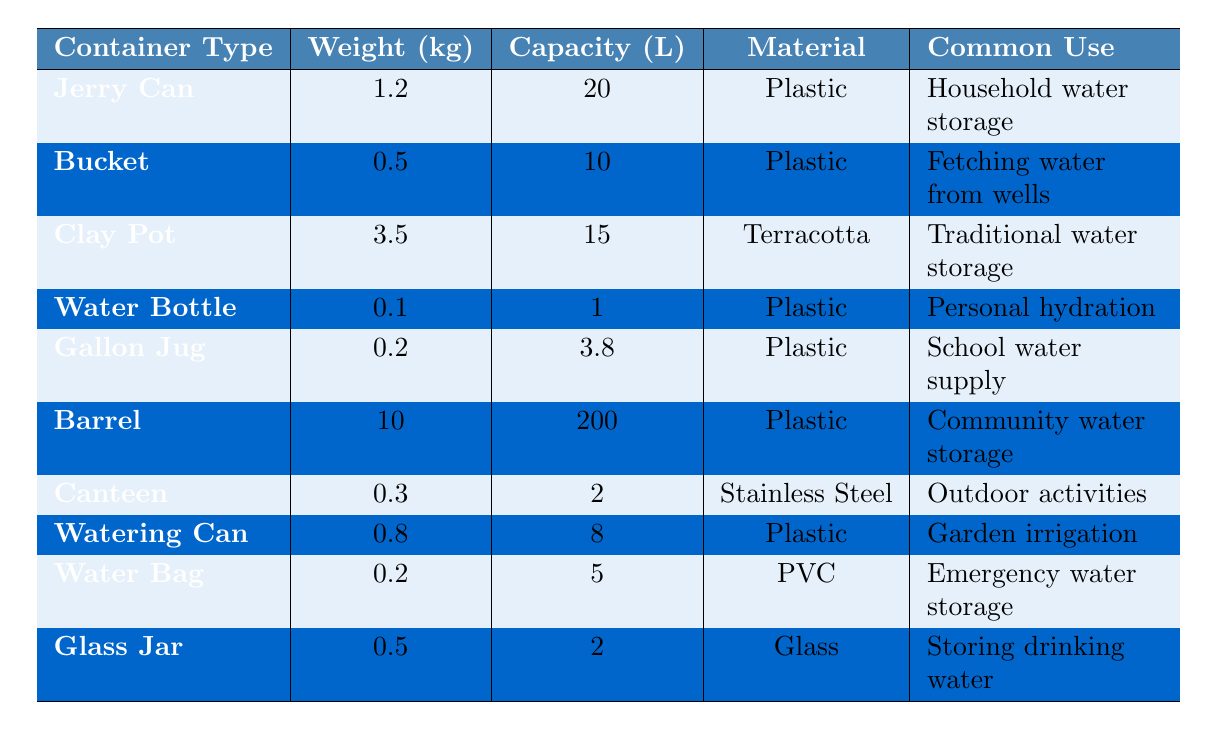What's the weight of a jerry can? The table lists the weight of a jerry can as 1.2 kg.
Answer: 1.2 kg Which container has the largest capacity? The barrel has the largest capacity of 200 liters, as seen in the table.
Answer: 200 liters How much does a clay pot weigh compared to a water bag? A clay pot weighs 3.5 kg, while a water bag weighs 0.2 kg. The difference is 3.5 - 0.2 = 3.3 kg, meaning the clay pot is heavier by this amount.
Answer: 3.3 kg Is the water bottle heavier than the gallon jug? The weight of the water bottle is 0.1 kg, while the gallon jug weighs 0.2 kg; thus, the water bottle is lighter.
Answer: No What is the average capacity of the containers listed? To find the average capacity, sum the capacities: 20 + 10 + 15 + 1 + 3.8 + 200 + 2 + 8 + 5 + 2 = 272. Then divide by the number of containers (10): 272 / 10 = 27.2 liters.
Answer: 27.2 liters Which materials are used for the containers? The materials used are plastic, terracotta, stainless steel, and glass. This can be identified by looking at the "Material" column in the table.
Answer: Plastic, terracotta, stainless steel, glass How many containers are made of plastic? The table shows that there are 6 containers made of plastic: Jerry Can, Bucket, Gallon Jug, Barrel, Watering Can, and Water Bag.
Answer: 6 What is the total weight of all the containers combined? To find the total weight, convert the weights to numbers and sum them up: 1.2 + 0.5 + 3.5 + 0.1 + 0.2 + 10 + 0.3 + 0.8 + 0.2 + 0.5 = 17.8 kg.
Answer: 17.8 kg Which container is commonly used for emergency water storage? The water bag is commonly used for emergency water storage, as indicated in the "Common Use" column.
Answer: Water Bag How does the weight of a barrel compare to that of a watering can? The barrel weighs 10 kg, while the watering can weighs 0.8 kg. The difference in weight is 10 - 0.8 = 9.2 kg, meaning the barrel is significantly heavier.
Answer: 9.2 kg 